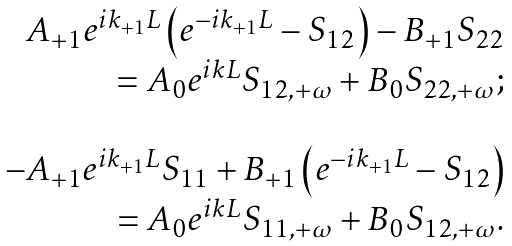Convert formula to latex. <formula><loc_0><loc_0><loc_500><loc_500>\begin{array} { r } A _ { + 1 } e ^ { i k _ { + 1 } L } \left ( e ^ { - i k _ { + 1 } L } - S _ { 1 2 } \right ) - B _ { + 1 } S _ { 2 2 } \\ = A _ { 0 } e ^ { i k L } S _ { 1 2 , + \omega } + B _ { 0 } S _ { 2 2 , + \omega } ; \\ \ \\ - A _ { + 1 } e ^ { i k _ { + 1 } L } S _ { 1 1 } + B _ { + 1 } \left ( e ^ { - i k _ { + 1 } L } - S _ { 1 2 } \right ) \\ = A _ { 0 } e ^ { i k L } S _ { 1 1 , + \omega } + B _ { 0 } S _ { 1 2 , + \omega } . \end{array}</formula> 